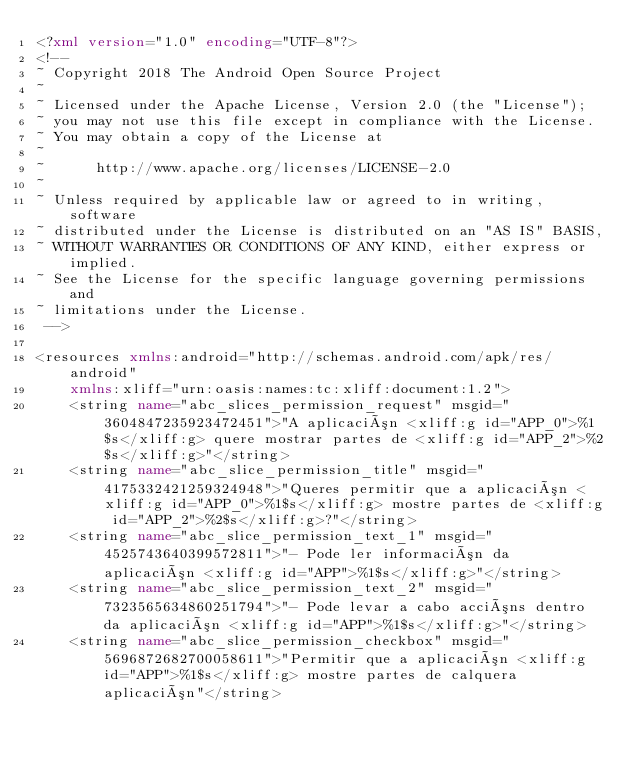<code> <loc_0><loc_0><loc_500><loc_500><_XML_><?xml version="1.0" encoding="UTF-8"?>
<!-- 
~ Copyright 2018 The Android Open Source Project
~
~ Licensed under the Apache License, Version 2.0 (the "License");
~ you may not use this file except in compliance with the License.
~ You may obtain a copy of the License at
~
~      http://www.apache.org/licenses/LICENSE-2.0
~
~ Unless required by applicable law or agreed to in writing, software
~ distributed under the License is distributed on an "AS IS" BASIS,
~ WITHOUT WARRANTIES OR CONDITIONS OF ANY KIND, either express or implied.
~ See the License for the specific language governing permissions and
~ limitations under the License.
 -->

<resources xmlns:android="http://schemas.android.com/apk/res/android"
    xmlns:xliff="urn:oasis:names:tc:xliff:document:1.2">
    <string name="abc_slices_permission_request" msgid="3604847235923472451">"A aplicación <xliff:g id="APP_0">%1$s</xliff:g> quere mostrar partes de <xliff:g id="APP_2">%2$s</xliff:g>"</string>
    <string name="abc_slice_permission_title" msgid="4175332421259324948">"Queres permitir que a aplicación <xliff:g id="APP_0">%1$s</xliff:g> mostre partes de <xliff:g id="APP_2">%2$s</xliff:g>?"</string>
    <string name="abc_slice_permission_text_1" msgid="4525743640399572811">"- Pode ler información da aplicación <xliff:g id="APP">%1$s</xliff:g>"</string>
    <string name="abc_slice_permission_text_2" msgid="7323565634860251794">"- Pode levar a cabo accións dentro da aplicación <xliff:g id="APP">%1$s</xliff:g>"</string>
    <string name="abc_slice_permission_checkbox" msgid="5696872682700058611">"Permitir que a aplicación <xliff:g id="APP">%1$s</xliff:g> mostre partes de calquera aplicación"</string></code> 